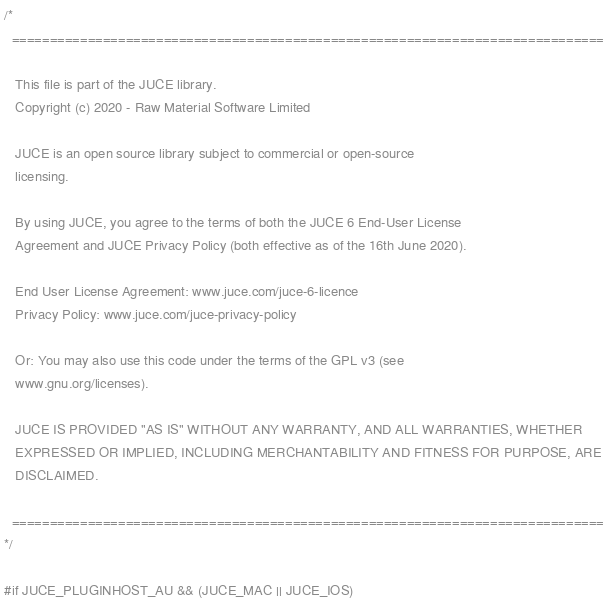Convert code to text. <code><loc_0><loc_0><loc_500><loc_500><_ObjectiveC_>/*
  ==============================================================================

   This file is part of the JUCE library.
   Copyright (c) 2020 - Raw Material Software Limited

   JUCE is an open source library subject to commercial or open-source
   licensing.

   By using JUCE, you agree to the terms of both the JUCE 6 End-User License
   Agreement and JUCE Privacy Policy (both effective as of the 16th June 2020).

   End User License Agreement: www.juce.com/juce-6-licence
   Privacy Policy: www.juce.com/juce-privacy-policy

   Or: You may also use this code under the terms of the GPL v3 (see
   www.gnu.org/licenses).

   JUCE IS PROVIDED "AS IS" WITHOUT ANY WARRANTY, AND ALL WARRANTIES, WHETHER
   EXPRESSED OR IMPLIED, INCLUDING MERCHANTABILITY AND FITNESS FOR PURPOSE, ARE
   DISCLAIMED.

  ==============================================================================
*/

#if JUCE_PLUGINHOST_AU && (JUCE_MAC || JUCE_IOS)
</code> 